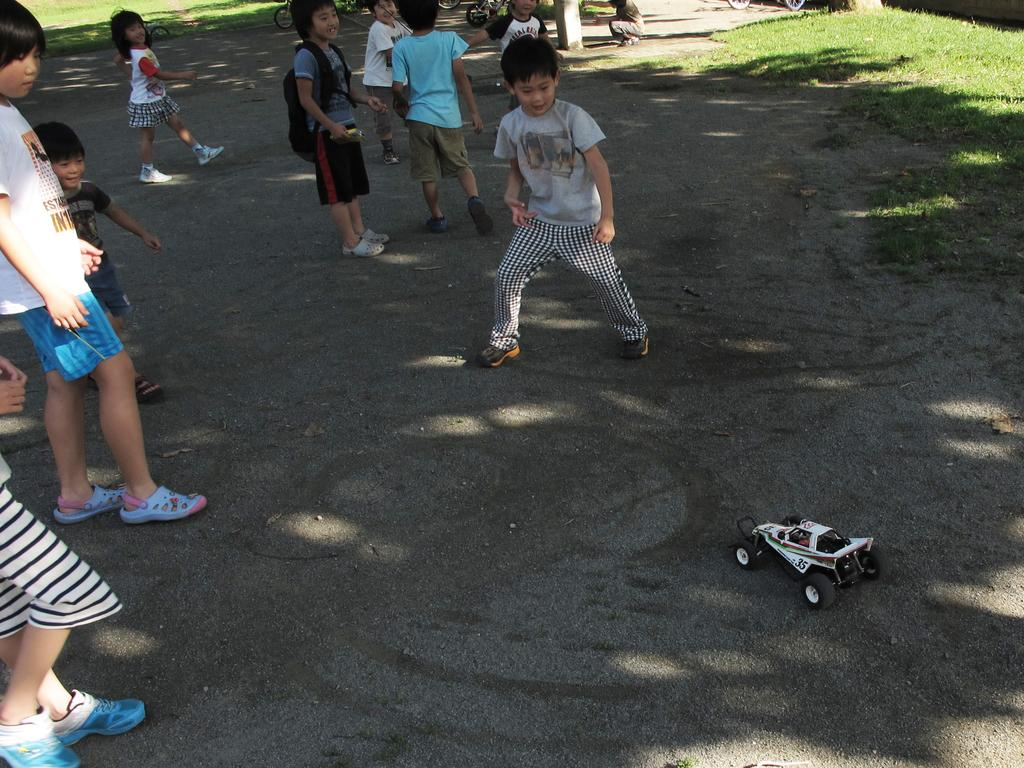What is the main subject of the image? The main subject of the image is a group of children. Where are the children located in the image? The children are standing on the ground. What else can be seen on the ground in the image? There is a toy on the ground. What type of natural environment is visible in the background of the image? There is grass visible in the background of the image. What other objects can be seen in the background of the image? There are other objects in the background of the image. What type of circle can be seen in the image? There is no circle present in the image. What type of space object can be seen in the image? There are no space objects present in the image. 